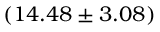Convert formula to latex. <formula><loc_0><loc_0><loc_500><loc_500>( 1 4 . 4 8 \pm 3 . 0 8 ) \</formula> 